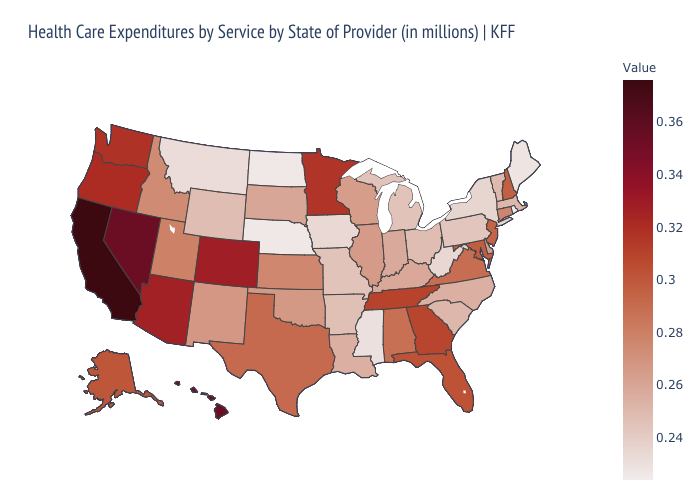Which states have the lowest value in the USA?
Concise answer only. Rhode Island. Among the states that border Louisiana , which have the lowest value?
Write a very short answer. Mississippi. Which states have the lowest value in the West?
Write a very short answer. Montana. Which states have the highest value in the USA?
Quick response, please. California. Which states have the highest value in the USA?
Write a very short answer. California. 